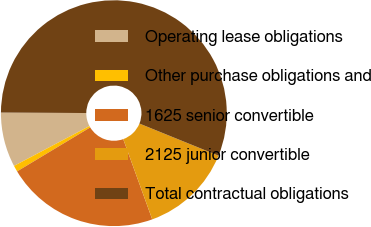Convert chart. <chart><loc_0><loc_0><loc_500><loc_500><pie_chart><fcel>Operating lease obligations<fcel>Other purchase obligations and<fcel>1625 senior convertible<fcel>2125 junior convertible<fcel>Total contractual obligations<nl><fcel>7.82%<fcel>0.89%<fcel>21.9%<fcel>13.34%<fcel>56.05%<nl></chart> 